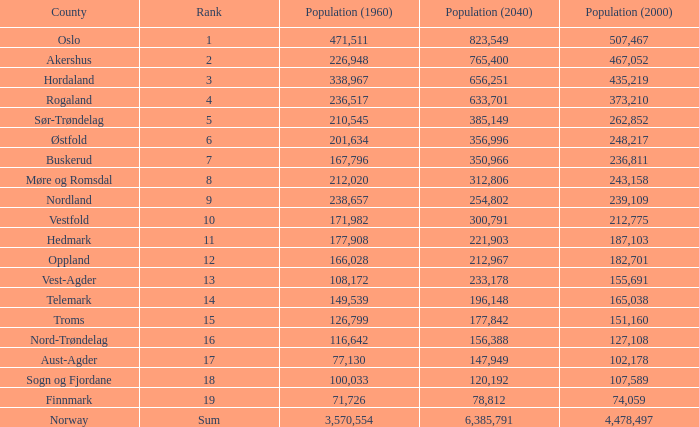What was Oslo's population in 1960, with a population of 507,467 in 2000? None. 